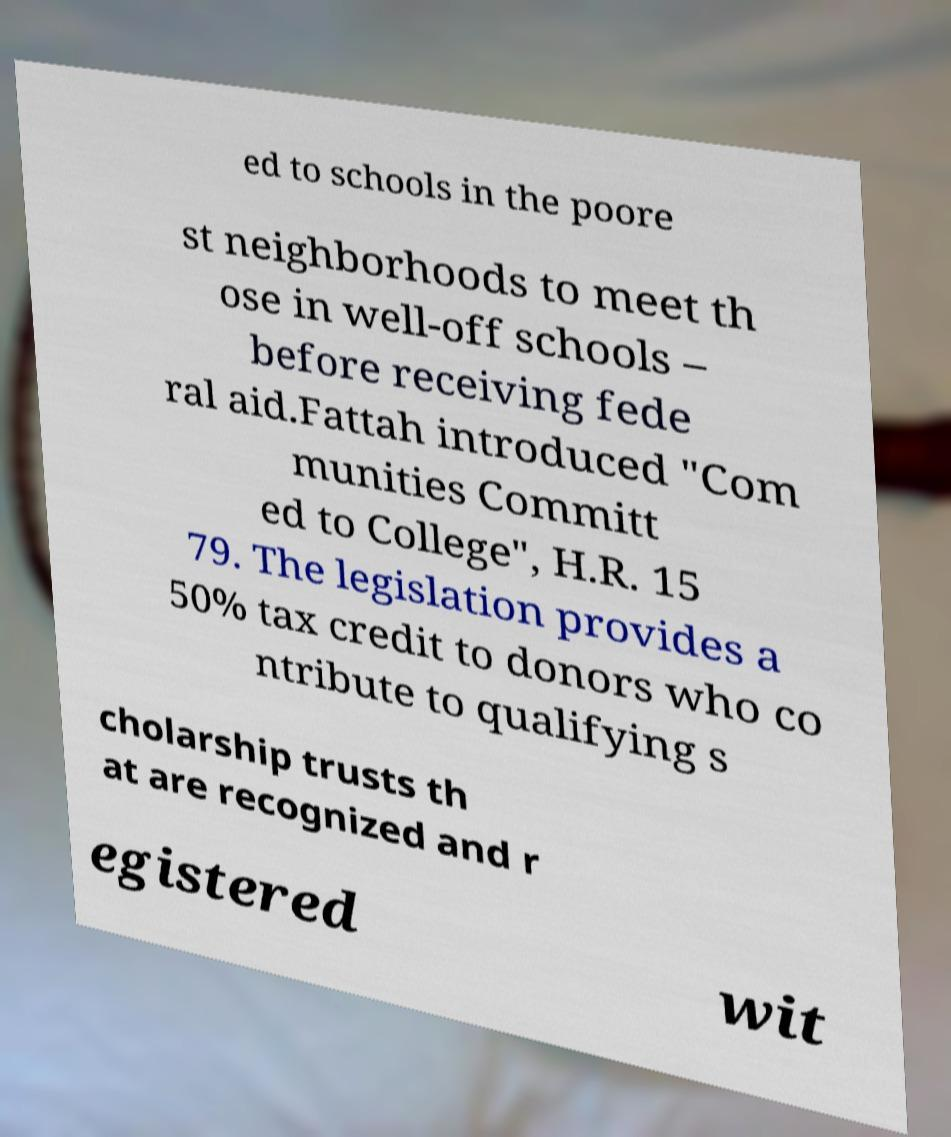Could you assist in decoding the text presented in this image and type it out clearly? ed to schools in the poore st neighborhoods to meet th ose in well-off schools – before receiving fede ral aid.Fattah introduced "Com munities Committ ed to College", H.R. 15 79. The legislation provides a 50% tax credit to donors who co ntribute to qualifying s cholarship trusts th at are recognized and r egistered wit 